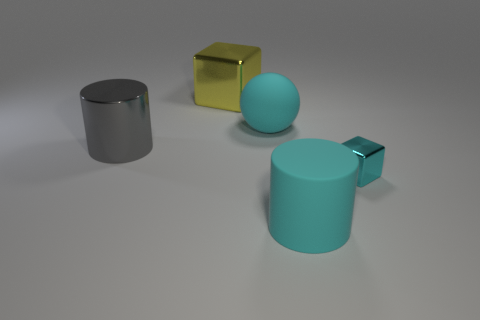How many other objects are the same shape as the yellow thing?
Make the answer very short. 1. There is a large thing that is in front of the large yellow object and on the left side of the big sphere; what is its color?
Your answer should be very brief. Gray. What is the color of the tiny metallic object?
Provide a succinct answer. Cyan. Are the big gray object and the big cylinder in front of the large gray object made of the same material?
Offer a very short reply. No. The small thing that is the same material as the yellow cube is what shape?
Provide a short and direct response. Cube. There is a block that is the same size as the cyan matte ball; what color is it?
Keep it short and to the point. Yellow. There is a shiny object that is left of the yellow block; is it the same size as the large yellow cube?
Keep it short and to the point. Yes. Is the sphere the same color as the tiny object?
Your response must be concise. Yes. What number of big blue objects are there?
Provide a succinct answer. 0. What number of spheres are cyan rubber objects or large gray things?
Your answer should be compact. 1. 